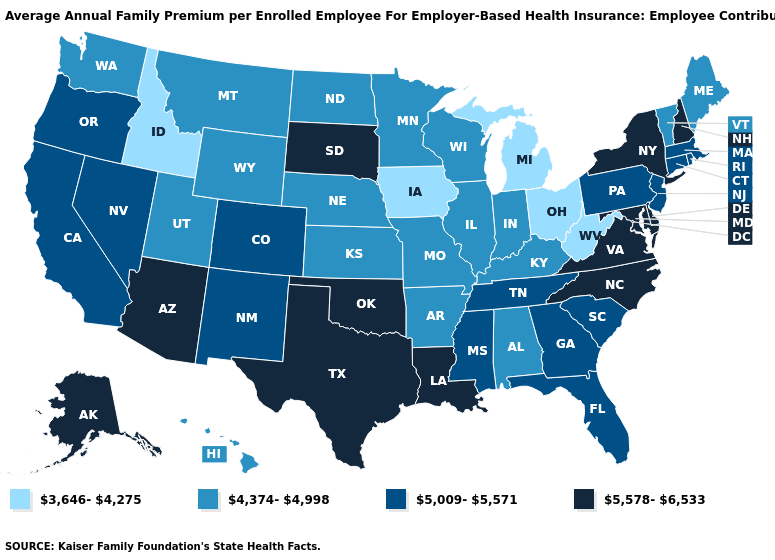Which states have the lowest value in the USA?
Write a very short answer. Idaho, Iowa, Michigan, Ohio, West Virginia. What is the value of Minnesota?
Be succinct. 4,374-4,998. Name the states that have a value in the range 4,374-4,998?
Concise answer only. Alabama, Arkansas, Hawaii, Illinois, Indiana, Kansas, Kentucky, Maine, Minnesota, Missouri, Montana, Nebraska, North Dakota, Utah, Vermont, Washington, Wisconsin, Wyoming. Which states hav the highest value in the West?
Quick response, please. Alaska, Arizona. Is the legend a continuous bar?
Quick response, please. No. What is the value of Pennsylvania?
Concise answer only. 5,009-5,571. What is the value of Minnesota?
Answer briefly. 4,374-4,998. Name the states that have a value in the range 3,646-4,275?
Be succinct. Idaho, Iowa, Michigan, Ohio, West Virginia. Name the states that have a value in the range 5,578-6,533?
Give a very brief answer. Alaska, Arizona, Delaware, Louisiana, Maryland, New Hampshire, New York, North Carolina, Oklahoma, South Dakota, Texas, Virginia. Name the states that have a value in the range 5,578-6,533?
Be succinct. Alaska, Arizona, Delaware, Louisiana, Maryland, New Hampshire, New York, North Carolina, Oklahoma, South Dakota, Texas, Virginia. What is the value of North Carolina?
Concise answer only. 5,578-6,533. What is the value of Rhode Island?
Be succinct. 5,009-5,571. What is the value of Oregon?
Quick response, please. 5,009-5,571. Name the states that have a value in the range 5,009-5,571?
Answer briefly. California, Colorado, Connecticut, Florida, Georgia, Massachusetts, Mississippi, Nevada, New Jersey, New Mexico, Oregon, Pennsylvania, Rhode Island, South Carolina, Tennessee. Which states have the lowest value in the South?
Concise answer only. West Virginia. 